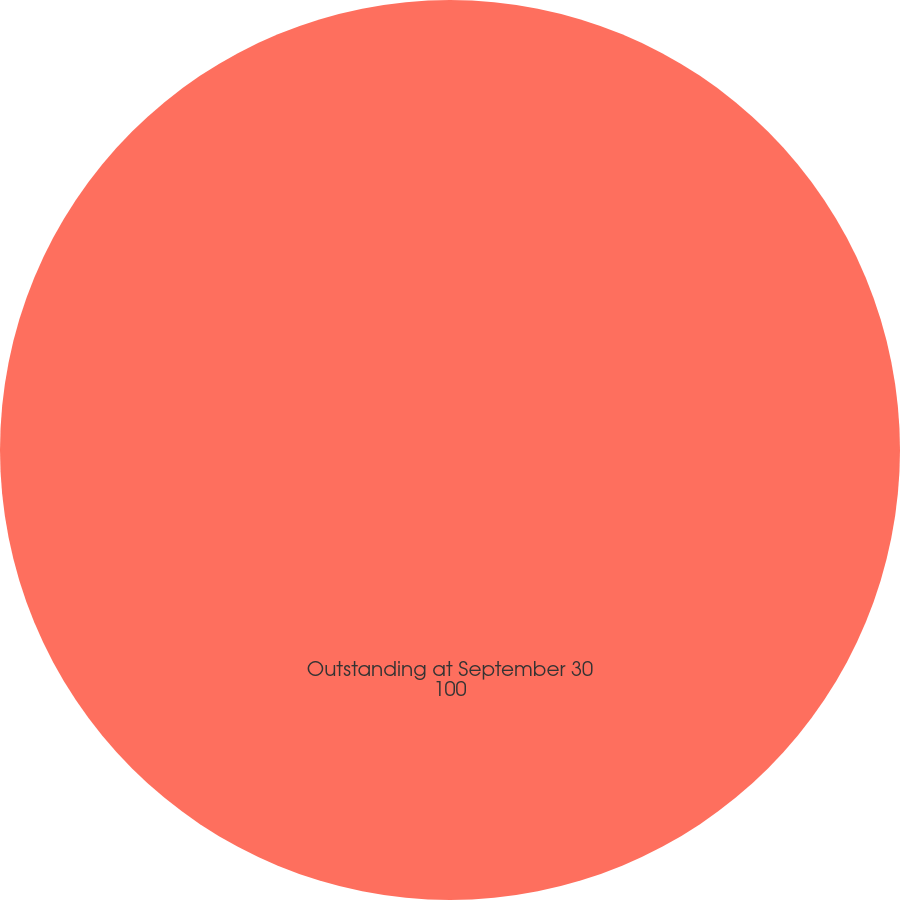Convert chart to OTSL. <chart><loc_0><loc_0><loc_500><loc_500><pie_chart><fcel>Outstanding at September 30<nl><fcel>100.0%<nl></chart> 